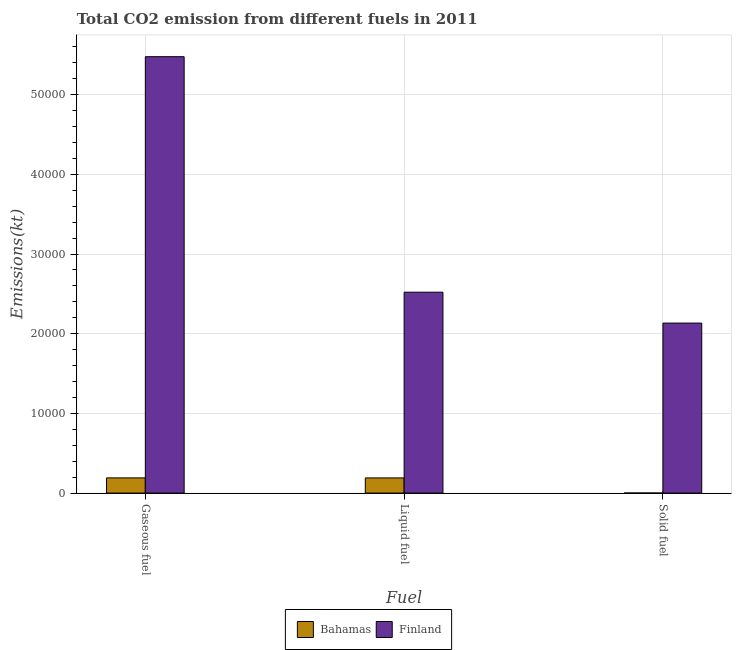How many different coloured bars are there?
Give a very brief answer. 2. How many groups of bars are there?
Keep it short and to the point. 3. How many bars are there on the 1st tick from the left?
Your answer should be compact. 2. What is the label of the 1st group of bars from the left?
Offer a terse response. Gaseous fuel. What is the amount of co2 emissions from solid fuel in Bahamas?
Provide a succinct answer. 3.67. Across all countries, what is the maximum amount of co2 emissions from solid fuel?
Offer a terse response. 2.13e+04. Across all countries, what is the minimum amount of co2 emissions from liquid fuel?
Make the answer very short. 1899.51. In which country was the amount of co2 emissions from gaseous fuel maximum?
Offer a terse response. Finland. In which country was the amount of co2 emissions from solid fuel minimum?
Offer a very short reply. Bahamas. What is the total amount of co2 emissions from solid fuel in the graph?
Give a very brief answer. 2.13e+04. What is the difference between the amount of co2 emissions from gaseous fuel in Bahamas and that in Finland?
Offer a very short reply. -5.29e+04. What is the difference between the amount of co2 emissions from solid fuel in Finland and the amount of co2 emissions from liquid fuel in Bahamas?
Provide a succinct answer. 1.94e+04. What is the average amount of co2 emissions from gaseous fuel per country?
Your answer should be compact. 2.83e+04. What is the difference between the amount of co2 emissions from gaseous fuel and amount of co2 emissions from solid fuel in Finland?
Give a very brief answer. 3.34e+04. What is the ratio of the amount of co2 emissions from liquid fuel in Bahamas to that in Finland?
Ensure brevity in your answer.  0.08. Is the amount of co2 emissions from solid fuel in Finland less than that in Bahamas?
Provide a short and direct response. No. What is the difference between the highest and the second highest amount of co2 emissions from liquid fuel?
Provide a short and direct response. 2.33e+04. What is the difference between the highest and the lowest amount of co2 emissions from solid fuel?
Give a very brief answer. 2.13e+04. In how many countries, is the amount of co2 emissions from gaseous fuel greater than the average amount of co2 emissions from gaseous fuel taken over all countries?
Offer a terse response. 1. What does the 1st bar from the left in Liquid fuel represents?
Ensure brevity in your answer.  Bahamas. What does the 1st bar from the right in Solid fuel represents?
Keep it short and to the point. Finland. Is it the case that in every country, the sum of the amount of co2 emissions from gaseous fuel and amount of co2 emissions from liquid fuel is greater than the amount of co2 emissions from solid fuel?
Your answer should be very brief. Yes. How many bars are there?
Offer a terse response. 6. What is the difference between two consecutive major ticks on the Y-axis?
Offer a terse response. 10000. Does the graph contain any zero values?
Give a very brief answer. No. How are the legend labels stacked?
Make the answer very short. Horizontal. What is the title of the graph?
Offer a very short reply. Total CO2 emission from different fuels in 2011. Does "Congo (Democratic)" appear as one of the legend labels in the graph?
Offer a very short reply. No. What is the label or title of the X-axis?
Ensure brevity in your answer.  Fuel. What is the label or title of the Y-axis?
Keep it short and to the point. Emissions(kt). What is the Emissions(kt) in Bahamas in Gaseous fuel?
Offer a very short reply. 1906.84. What is the Emissions(kt) of Finland in Gaseous fuel?
Your response must be concise. 5.48e+04. What is the Emissions(kt) of Bahamas in Liquid fuel?
Your response must be concise. 1899.51. What is the Emissions(kt) in Finland in Liquid fuel?
Provide a succinct answer. 2.52e+04. What is the Emissions(kt) of Bahamas in Solid fuel?
Provide a succinct answer. 3.67. What is the Emissions(kt) in Finland in Solid fuel?
Make the answer very short. 2.13e+04. Across all Fuel, what is the maximum Emissions(kt) in Bahamas?
Keep it short and to the point. 1906.84. Across all Fuel, what is the maximum Emissions(kt) of Finland?
Keep it short and to the point. 5.48e+04. Across all Fuel, what is the minimum Emissions(kt) in Bahamas?
Offer a very short reply. 3.67. Across all Fuel, what is the minimum Emissions(kt) in Finland?
Give a very brief answer. 2.13e+04. What is the total Emissions(kt) in Bahamas in the graph?
Ensure brevity in your answer.  3810.01. What is the total Emissions(kt) in Finland in the graph?
Make the answer very short. 1.01e+05. What is the difference between the Emissions(kt) in Bahamas in Gaseous fuel and that in Liquid fuel?
Provide a succinct answer. 7.33. What is the difference between the Emissions(kt) of Finland in Gaseous fuel and that in Liquid fuel?
Provide a succinct answer. 2.96e+04. What is the difference between the Emissions(kt) in Bahamas in Gaseous fuel and that in Solid fuel?
Keep it short and to the point. 1903.17. What is the difference between the Emissions(kt) of Finland in Gaseous fuel and that in Solid fuel?
Provide a succinct answer. 3.34e+04. What is the difference between the Emissions(kt) of Bahamas in Liquid fuel and that in Solid fuel?
Offer a very short reply. 1895.84. What is the difference between the Emissions(kt) in Finland in Liquid fuel and that in Solid fuel?
Offer a terse response. 3876.02. What is the difference between the Emissions(kt) of Bahamas in Gaseous fuel and the Emissions(kt) of Finland in Liquid fuel?
Your response must be concise. -2.33e+04. What is the difference between the Emissions(kt) in Bahamas in Gaseous fuel and the Emissions(kt) in Finland in Solid fuel?
Give a very brief answer. -1.94e+04. What is the difference between the Emissions(kt) in Bahamas in Liquid fuel and the Emissions(kt) in Finland in Solid fuel?
Provide a short and direct response. -1.94e+04. What is the average Emissions(kt) in Bahamas per Fuel?
Provide a short and direct response. 1270. What is the average Emissions(kt) in Finland per Fuel?
Provide a succinct answer. 3.38e+04. What is the difference between the Emissions(kt) in Bahamas and Emissions(kt) in Finland in Gaseous fuel?
Your response must be concise. -5.29e+04. What is the difference between the Emissions(kt) in Bahamas and Emissions(kt) in Finland in Liquid fuel?
Your response must be concise. -2.33e+04. What is the difference between the Emissions(kt) in Bahamas and Emissions(kt) in Finland in Solid fuel?
Your answer should be very brief. -2.13e+04. What is the ratio of the Emissions(kt) in Bahamas in Gaseous fuel to that in Liquid fuel?
Ensure brevity in your answer.  1. What is the ratio of the Emissions(kt) of Finland in Gaseous fuel to that in Liquid fuel?
Your response must be concise. 2.17. What is the ratio of the Emissions(kt) in Bahamas in Gaseous fuel to that in Solid fuel?
Keep it short and to the point. 520. What is the ratio of the Emissions(kt) in Finland in Gaseous fuel to that in Solid fuel?
Give a very brief answer. 2.57. What is the ratio of the Emissions(kt) in Bahamas in Liquid fuel to that in Solid fuel?
Make the answer very short. 518. What is the ratio of the Emissions(kt) in Finland in Liquid fuel to that in Solid fuel?
Your answer should be compact. 1.18. What is the difference between the highest and the second highest Emissions(kt) in Bahamas?
Provide a succinct answer. 7.33. What is the difference between the highest and the second highest Emissions(kt) in Finland?
Provide a short and direct response. 2.96e+04. What is the difference between the highest and the lowest Emissions(kt) in Bahamas?
Your answer should be very brief. 1903.17. What is the difference between the highest and the lowest Emissions(kt) in Finland?
Offer a very short reply. 3.34e+04. 